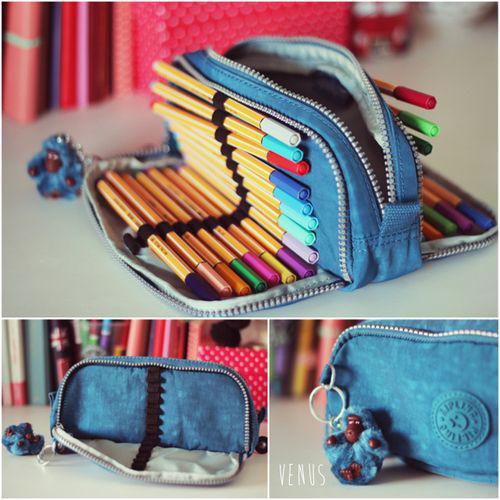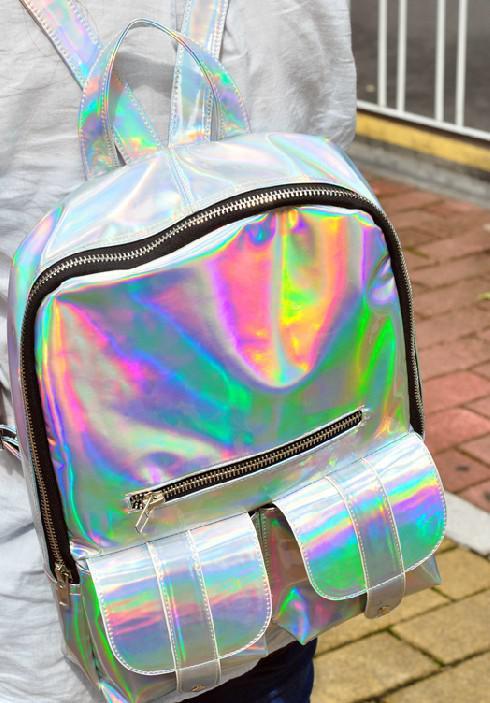The first image is the image on the left, the second image is the image on the right. For the images displayed, is the sentence "A blue pencil case is holding several pencils." factually correct? Answer yes or no. Yes. 